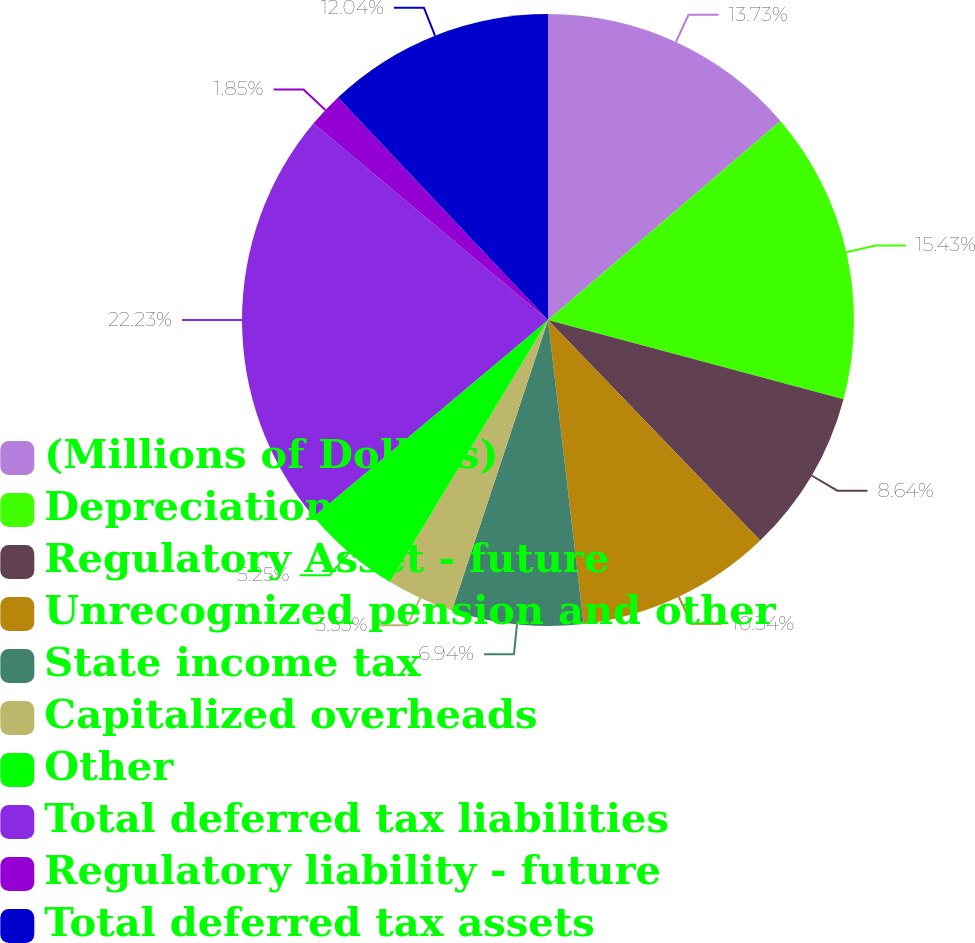<chart> <loc_0><loc_0><loc_500><loc_500><pie_chart><fcel>(Millions of Dollars)<fcel>Depreciation<fcel>Regulatory Asset - future<fcel>Unrecognized pension and other<fcel>State income tax<fcel>Capitalized overheads<fcel>Other<fcel>Total deferred tax liabilities<fcel>Regulatory liability - future<fcel>Total deferred tax assets<nl><fcel>13.73%<fcel>15.43%<fcel>8.64%<fcel>10.34%<fcel>6.94%<fcel>3.55%<fcel>5.25%<fcel>22.22%<fcel>1.85%<fcel>12.04%<nl></chart> 